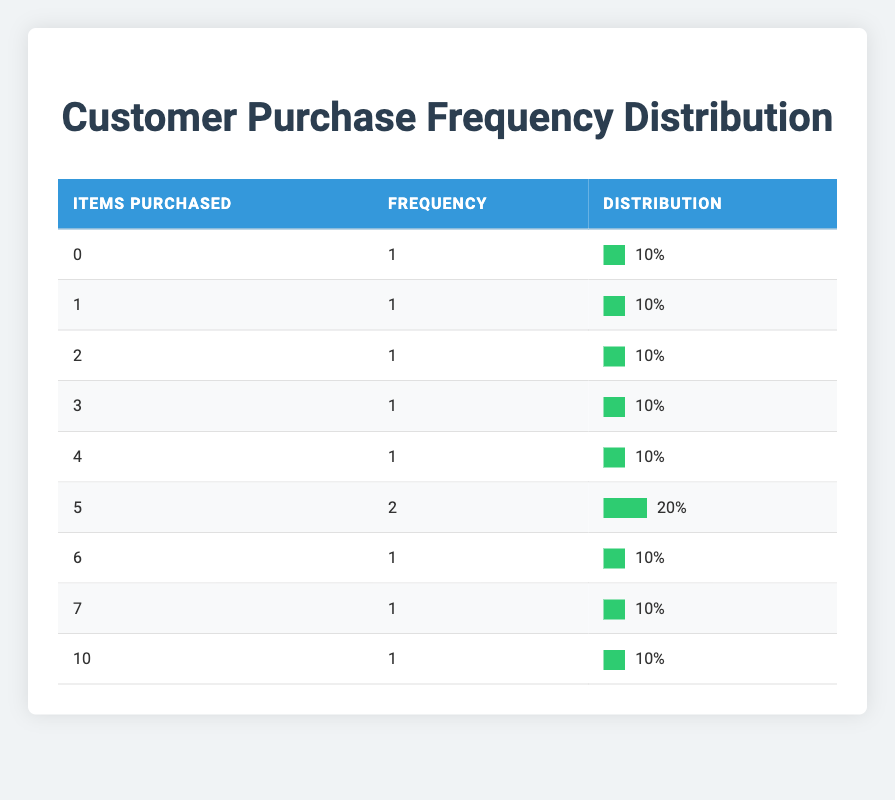What is the frequency of customers who purchased 5 items? The table shows that the frequency of customers who purchased 5 items is 2. This is indicated in the row where "Items Purchased" is 5 and the corresponding "Frequency" is 2.
Answer: 2 What percentage of customers purchased 0 items? The frequency of customers who purchased 0 items is 1. The total number of unique customers is 10. Therefore, the percentage is (1/10) * 100 = 10%. This percentage appears in the same row where "Items Purchased" is 0.
Answer: 10% How many customers purchased more than 6 items? From the table, there is only 1 customer who purchased more than 6 items (specifically, 10 items). This is noted in the row with "Items Purchased" equal to 10 and its "Frequency".
Answer: 1 What is the total number of customers who made purchases (any amount)? The table lists 10 different customer IDs, each associated with a purchase date and the number of items purchased. Therefore, the total number of customers who made purchases is 10.
Answer: 10 What is the average number of items purchased by customers? To find the average, we need to calculate the total number of items purchased and divide it by the number of customers. The sum of items purchased is (0 + 1 + 2 + 3 + 4 + 5*2 + 6 + 7 + 10) = 38. There are 10 customers, so the average is 38 / 10 = 3.8.
Answer: 3.8 Is it true that no customer purchased exactly 8 items? By examining the table, we can see that no row exists for customers who purchased 8 items, confirming that it is true no customer purchased this amount.
Answer: Yes Which purchase amount has the highest frequency? The maximum frequency is 2 for customers who purchased 5 items. This can be identified by looking through the "Frequency" column and comparing the values; 2 is the highest.
Answer: 5 items How many customers purchased less than 4 items? We need to add up the frequencies of rows where "Items Purchased" is 0, 1, 2, or 3. From the table, we see that there is a total of 4 customers: 1 who purchased 0 items, 1 who purchased 1 item, 1 who purchased 2 items, and 1 who purchased 3 items. Thus, 1 + 1 + 1 + 1 = 4 customers purchased less than 4 items.
Answer: 4 What can be said about the purchase pattern on November 26th? Only one customer purchased on November 26th, who bought 7 items. This is significant because it indicates lower overall activity on that date compared to others where multiple customers made numerous purchases, revealing a trend of less frequent shopping on this day.
Answer: One customer purchased 7 items 